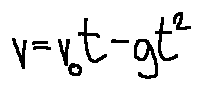<formula> <loc_0><loc_0><loc_500><loc_500>v = v _ { 0 } t - g t ^ { 2 }</formula> 